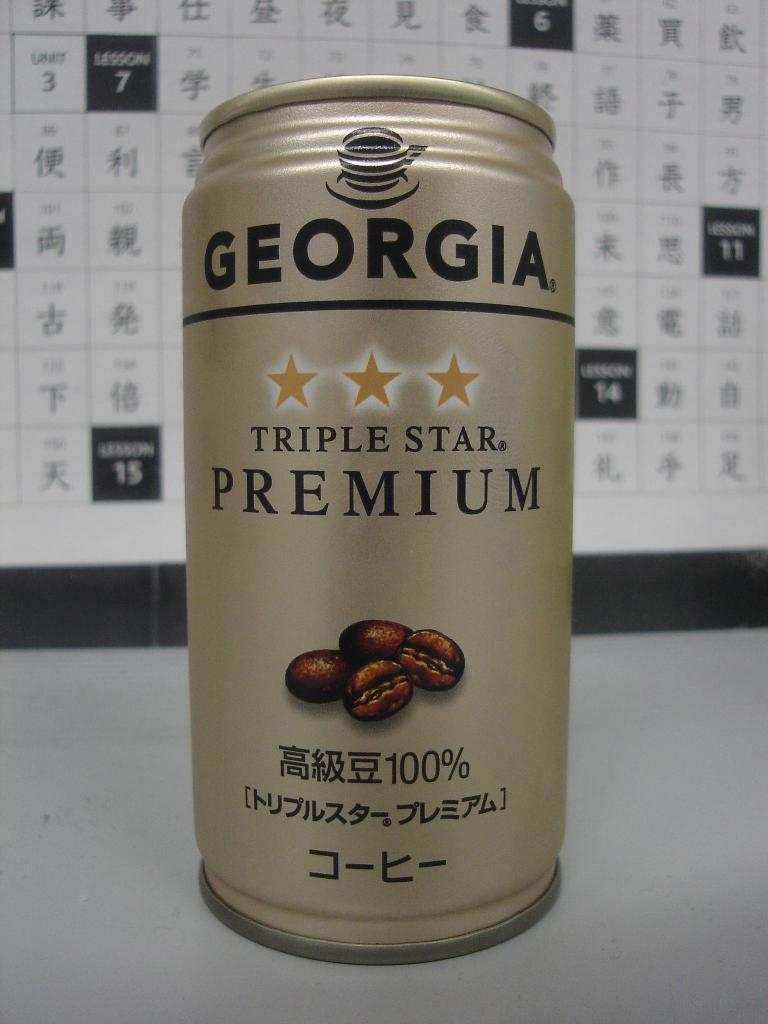<image>
Relay a brief, clear account of the picture shown. A can of GEORGIA Triple Star PREMIUM is pictured with four coffee beans on it. 